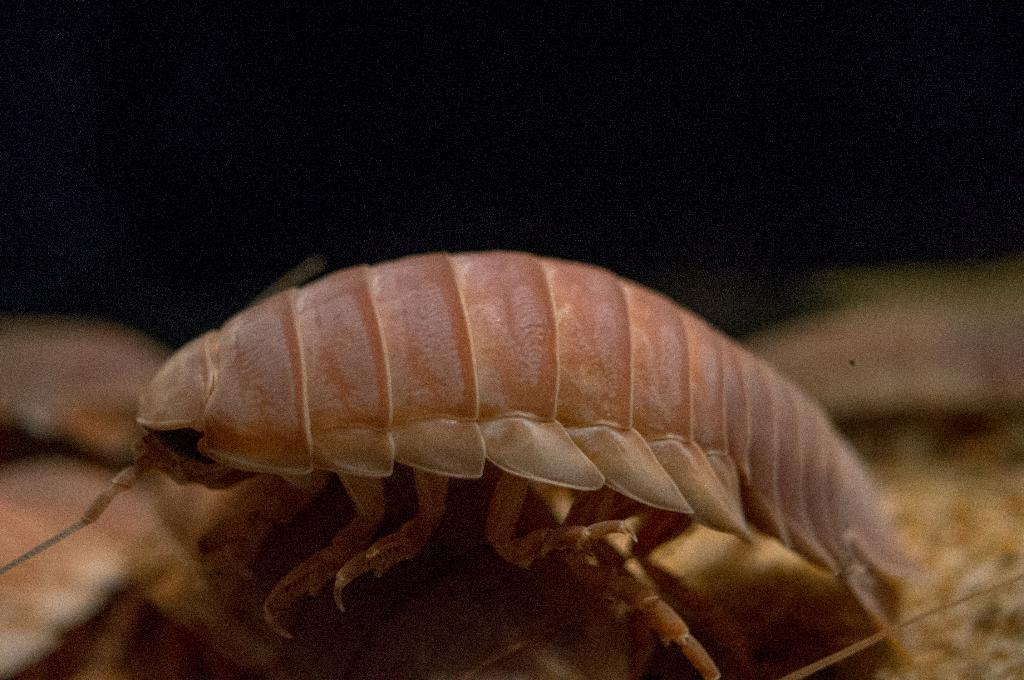What type of creature can be seen in the image? There is an insect in the image. What type of hen can be seen laying eggs near the border in the image? There is no hen or border present in the image; it only features an insect. 